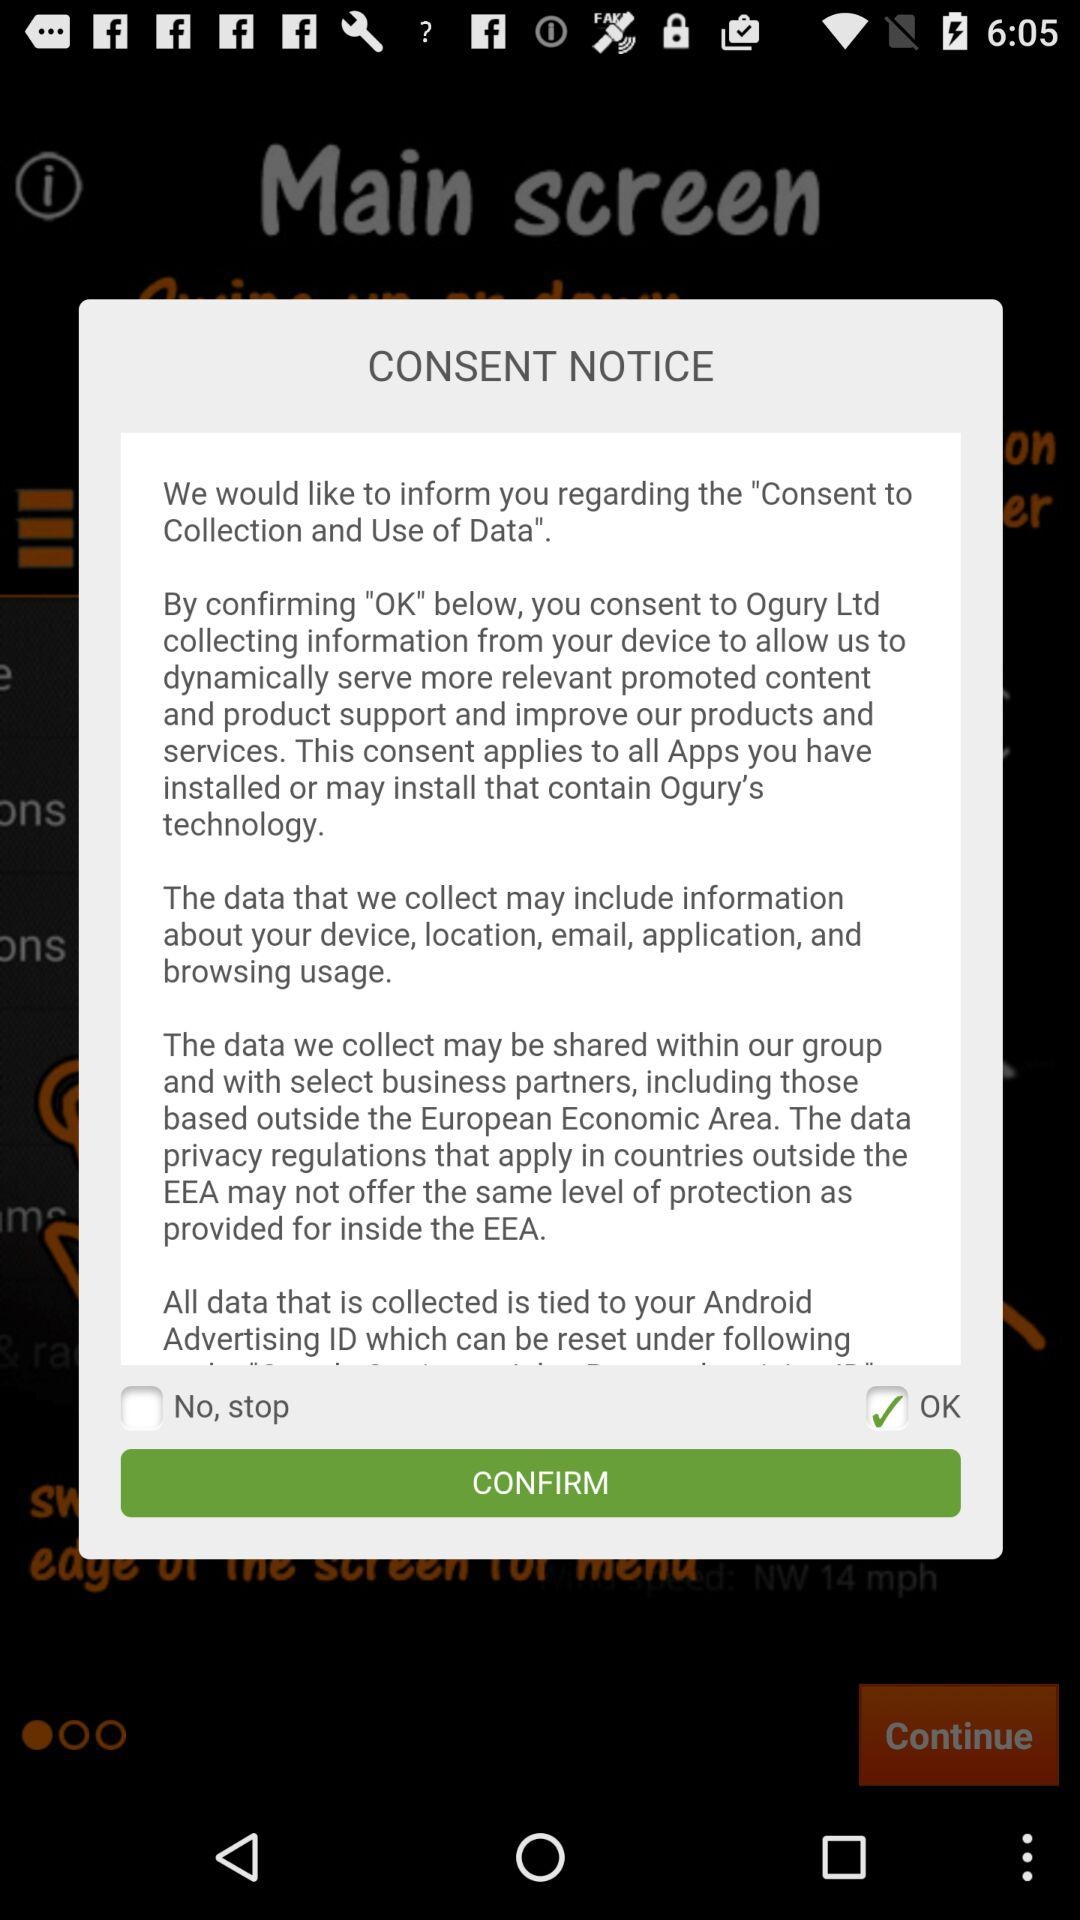What is the status of "OK"? The status is "on". 